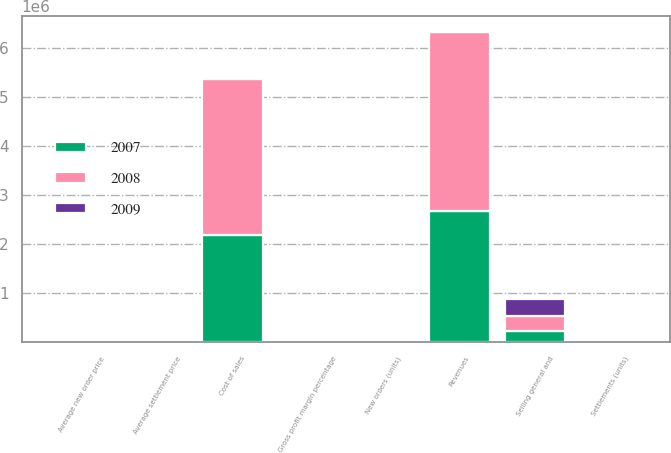Convert chart to OTSL. <chart><loc_0><loc_0><loc_500><loc_500><stacked_bar_chart><ecel><fcel>Revenues<fcel>Cost of sales<fcel>Gross profit margin percentage<fcel>Selling general and<fcel>Settlements (units)<fcel>Average settlement price<fcel>New orders (units)<fcel>Average new order price<nl><fcel>2007<fcel>2.68347e+06<fcel>2.18573e+06<fcel>18.5<fcel>233152<fcel>9042<fcel>296.4<fcel>9409<fcel>292.7<nl><fcel>2008<fcel>3.6387e+06<fcel>3.18101e+06<fcel>12.6<fcel>308739<fcel>10741<fcel>338.4<fcel>8760<fcel>311.3<nl><fcel>2009<fcel>9225.5<fcel>9225.5<fcel>16.3<fcel>343520<fcel>13513<fcel>373.2<fcel>12270<fcel>352<nl></chart> 